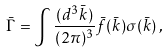<formula> <loc_0><loc_0><loc_500><loc_500>\bar { \Gamma } = \int \frac { ( d ^ { 3 } \bar { k } ) } { ( 2 \pi ) ^ { 3 } } \bar { f } ( { \bar { k } } ) \sigma ( { \bar { k } } ) \, ,</formula> 